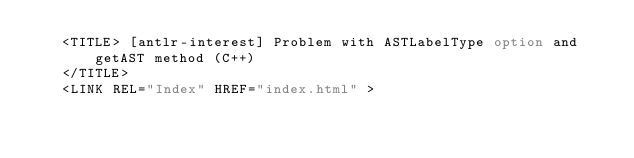Convert code to text. <code><loc_0><loc_0><loc_500><loc_500><_HTML_>   <TITLE> [antlr-interest] Problem with ASTLabelType option and getAST method (C++)
   </TITLE>
   <LINK REL="Index" HREF="index.html" ></code> 